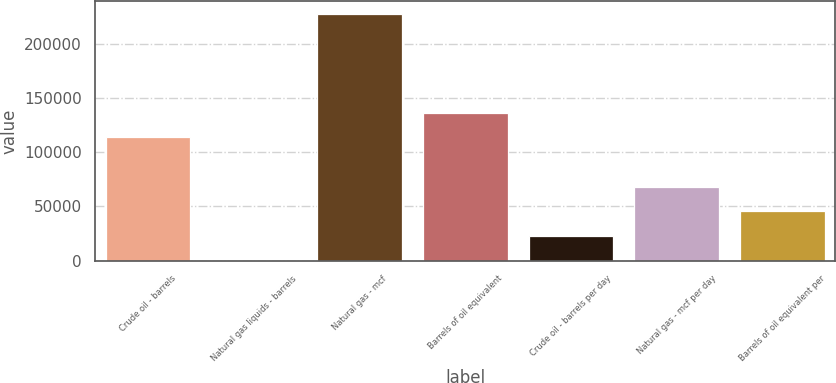Convert chart. <chart><loc_0><loc_0><loc_500><loc_500><bar_chart><fcel>Crude oil - barrels<fcel>Natural gas liquids - barrels<fcel>Natural gas - mcf<fcel>Barrels of oil equivalent<fcel>Crude oil - barrels per day<fcel>Natural gas - mcf per day<fcel>Barrels of oil equivalent per<nl><fcel>113674<fcel>17<fcel>227331<fcel>136470<fcel>22748.4<fcel>68211.2<fcel>45479.8<nl></chart> 